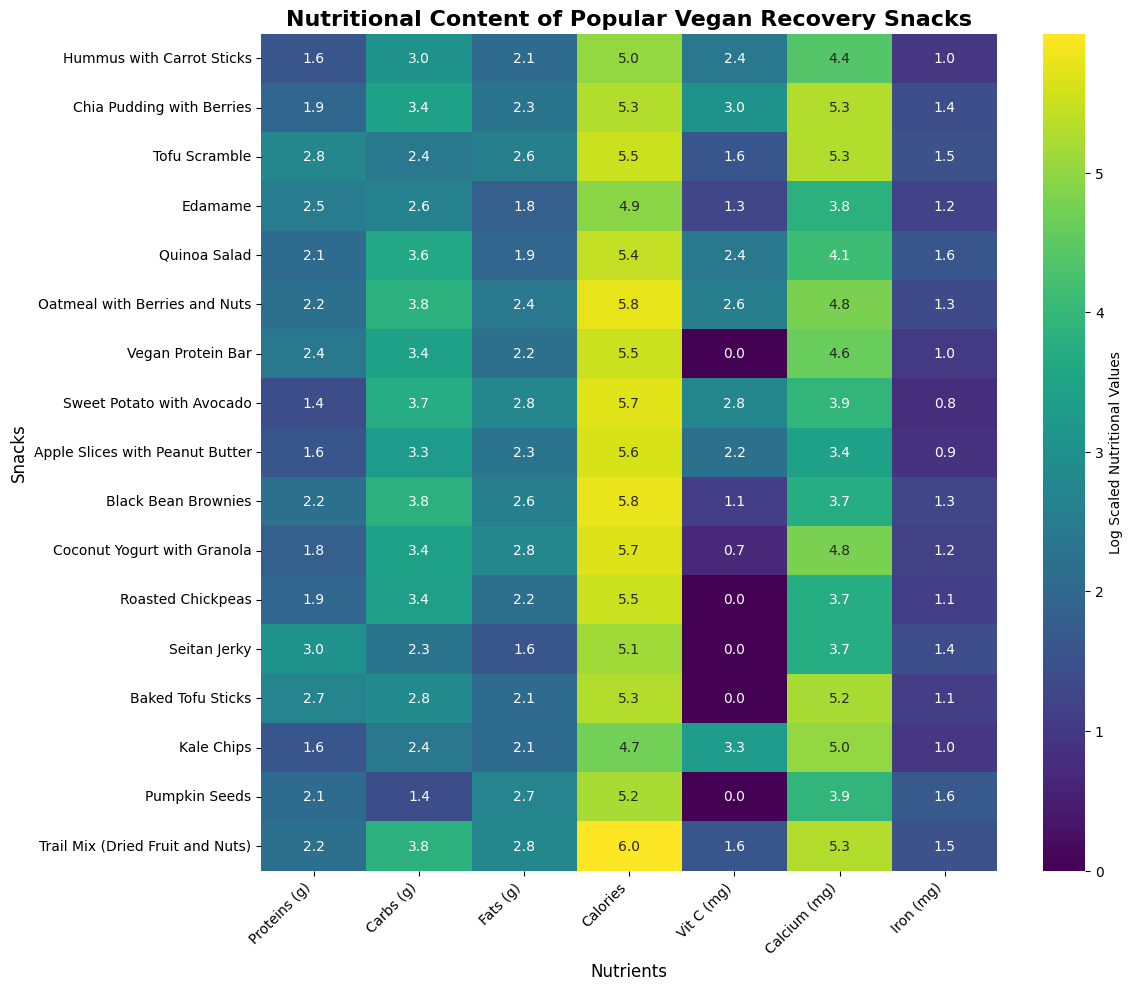What snack has the highest protein content? Look at the column titled "Proteins (g)" in the heatmap. Locate the snack with the highest value in this column. Seitan Jerky has the highest protein content with a log-scaled value that is visibly the highest among all snacks.
Answer: Seitan Jerky How do the carbohydrates in Oatmeal with Berries and Nuts compare to those in Quinoa Salad? Identify the "Carbs (g)" column in the heatmap. Compare the log-scaled values for Oatmeal with Berries and Nuts and Quinoa Salad. Oatmeal with Berries and Nuts shows a higher log-scaled value compared with Quinoa Salad.
Answer: Oatmeal with Berries and Nuts has more carbohydrates Which snacks have a log-scaled Vitamin C value greater than 2? Check the "Vit C (mg)" column in the heatmap and identify the snacks with values greater than 2. The snacks with such values are Sweet Potato with Avocado and Kale Chips.
Answer: Sweet Potato with Avocado, Kale Chips What is the difference in fat content between Sweet Potato with Avocado and Coconut Yogurt with Granola? Look at the "Fats (g)" column and compare the log-scaled values for Sweet Potato with Avocado and Coconut Yogurt with Granola. Find the absolute difference between these values, which will be small. The visual difference indicates that both are almost equal.
Answer: Approximately equal Which snack has the highest calcium content, and how much higher is it compared to Edamame? Examine the "Calcium (mg)" column to find the snack with the highest log-scaled value, which is Oatmeal with Berries and Nuts. Subtract the log-scaled value for Edamame from this highest value to find the difference. The exact difference can be derived from the lengths of the colored bars.
Answer: Oatmeal with Berries and Nuts, difference is around 2 Which snack has the lowest iron content? Look at the "Iron (mg)" column and locate the snack with the lowest value. Hummus with Carrot Sticks has the lowest iron content with a log-scaled value that is the smallest.
Answer: Hummus with Carrot Sticks How does the caloric content of Black Bean Brownies compare to Trail Mix (Dried Fruit and Nuts)? Check the "Calories" column and compare the log-scaled values for Black Bean Brownies and Trail Mix. Trail Mix appears to have a higher log-scaled value than Black Bean Brownies, indicating it has more calories.
Answer: Trail Mix has more calories What is the sum of carbohydrate content in Edamame and Roasted Chickpeas? Find the log-scaled values in the "Carbs (g)" column for both Edamame and Roasted Chickpeas and add them together. Sum these log-scaled values visually as around twice the value for either of them, as they have similar values and colors.
Answer: Sum is around the sum of Edamame and Roasted Chickpeas' logs Which snack has the highest log-scaled value for iron content and what is it? Look at the "Iron (mg)" column and locate the highest log-scaled value. Identify the corresponding snack as Pumpkin Seeds, which has the highest iron content.
Answer: Pumpkin Seeds, value around 1.6 